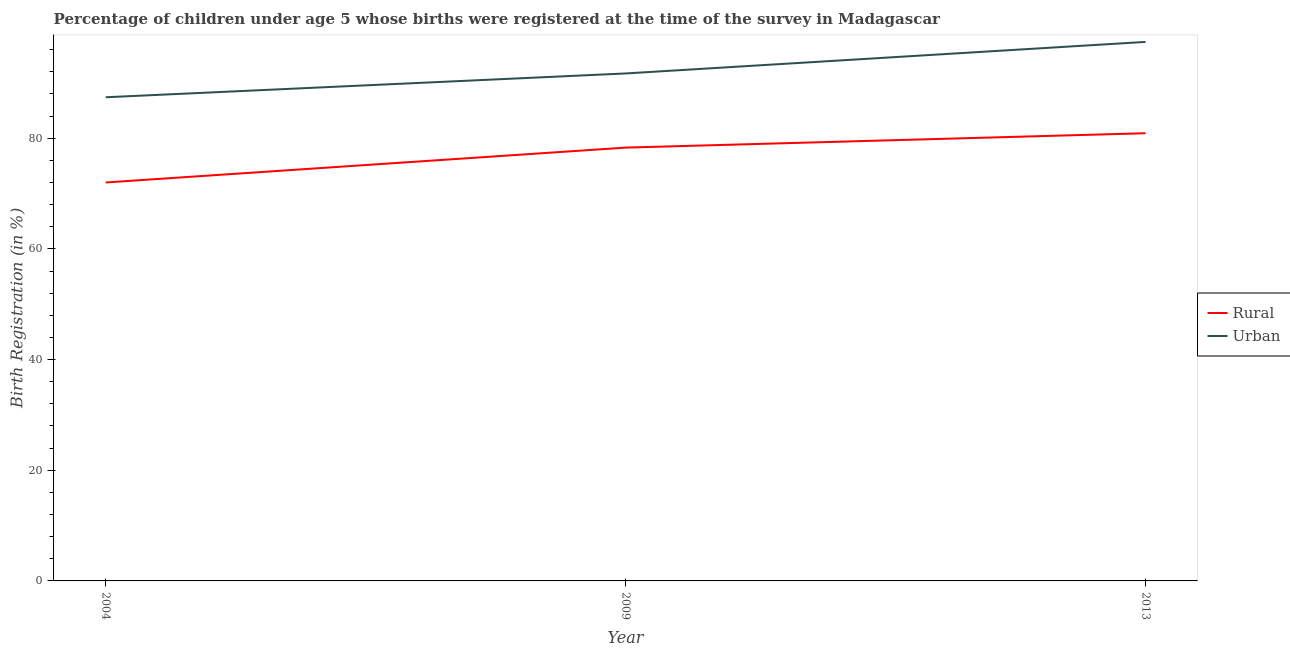Does the line corresponding to urban birth registration intersect with the line corresponding to rural birth registration?
Make the answer very short. No. What is the urban birth registration in 2009?
Give a very brief answer. 91.7. Across all years, what is the maximum urban birth registration?
Keep it short and to the point. 97.4. Across all years, what is the minimum rural birth registration?
Provide a short and direct response. 72. In which year was the rural birth registration maximum?
Ensure brevity in your answer.  2013. What is the total rural birth registration in the graph?
Offer a terse response. 231.2. What is the difference between the urban birth registration in 2004 and that in 2009?
Keep it short and to the point. -4.3. What is the average rural birth registration per year?
Give a very brief answer. 77.07. In the year 2013, what is the difference between the rural birth registration and urban birth registration?
Offer a terse response. -16.5. In how many years, is the rural birth registration greater than 80 %?
Offer a terse response. 1. What is the ratio of the rural birth registration in 2009 to that in 2013?
Your response must be concise. 0.97. Is the rural birth registration in 2004 less than that in 2009?
Provide a short and direct response. Yes. Is the difference between the rural birth registration in 2004 and 2013 greater than the difference between the urban birth registration in 2004 and 2013?
Offer a terse response. Yes. What is the difference between the highest and the second highest rural birth registration?
Offer a terse response. 2.6. What is the difference between the highest and the lowest rural birth registration?
Give a very brief answer. 8.9. Does the rural birth registration monotonically increase over the years?
Keep it short and to the point. Yes. How many lines are there?
Offer a terse response. 2. Does the graph contain any zero values?
Offer a terse response. No. Where does the legend appear in the graph?
Ensure brevity in your answer.  Center right. How many legend labels are there?
Provide a short and direct response. 2. What is the title of the graph?
Your answer should be very brief. Percentage of children under age 5 whose births were registered at the time of the survey in Madagascar. What is the label or title of the Y-axis?
Your response must be concise. Birth Registration (in %). What is the Birth Registration (in %) in Urban in 2004?
Your response must be concise. 87.4. What is the Birth Registration (in %) of Rural in 2009?
Your answer should be very brief. 78.3. What is the Birth Registration (in %) in Urban in 2009?
Ensure brevity in your answer.  91.7. What is the Birth Registration (in %) of Rural in 2013?
Offer a terse response. 80.9. What is the Birth Registration (in %) of Urban in 2013?
Keep it short and to the point. 97.4. Across all years, what is the maximum Birth Registration (in %) in Rural?
Your answer should be very brief. 80.9. Across all years, what is the maximum Birth Registration (in %) in Urban?
Your response must be concise. 97.4. Across all years, what is the minimum Birth Registration (in %) in Rural?
Give a very brief answer. 72. Across all years, what is the minimum Birth Registration (in %) in Urban?
Provide a short and direct response. 87.4. What is the total Birth Registration (in %) in Rural in the graph?
Offer a terse response. 231.2. What is the total Birth Registration (in %) of Urban in the graph?
Provide a short and direct response. 276.5. What is the difference between the Birth Registration (in %) of Urban in 2004 and that in 2009?
Offer a terse response. -4.3. What is the difference between the Birth Registration (in %) in Rural in 2004 and that in 2013?
Offer a very short reply. -8.9. What is the difference between the Birth Registration (in %) of Urban in 2004 and that in 2013?
Offer a very short reply. -10. What is the difference between the Birth Registration (in %) of Rural in 2009 and that in 2013?
Offer a terse response. -2.6. What is the difference between the Birth Registration (in %) of Rural in 2004 and the Birth Registration (in %) of Urban in 2009?
Your answer should be compact. -19.7. What is the difference between the Birth Registration (in %) in Rural in 2004 and the Birth Registration (in %) in Urban in 2013?
Provide a succinct answer. -25.4. What is the difference between the Birth Registration (in %) in Rural in 2009 and the Birth Registration (in %) in Urban in 2013?
Your response must be concise. -19.1. What is the average Birth Registration (in %) in Rural per year?
Give a very brief answer. 77.07. What is the average Birth Registration (in %) in Urban per year?
Your answer should be compact. 92.17. In the year 2004, what is the difference between the Birth Registration (in %) of Rural and Birth Registration (in %) of Urban?
Ensure brevity in your answer.  -15.4. In the year 2009, what is the difference between the Birth Registration (in %) in Rural and Birth Registration (in %) in Urban?
Your answer should be very brief. -13.4. In the year 2013, what is the difference between the Birth Registration (in %) of Rural and Birth Registration (in %) of Urban?
Give a very brief answer. -16.5. What is the ratio of the Birth Registration (in %) of Rural in 2004 to that in 2009?
Your response must be concise. 0.92. What is the ratio of the Birth Registration (in %) of Urban in 2004 to that in 2009?
Provide a short and direct response. 0.95. What is the ratio of the Birth Registration (in %) of Rural in 2004 to that in 2013?
Your answer should be very brief. 0.89. What is the ratio of the Birth Registration (in %) of Urban in 2004 to that in 2013?
Your response must be concise. 0.9. What is the ratio of the Birth Registration (in %) in Rural in 2009 to that in 2013?
Your answer should be very brief. 0.97. What is the ratio of the Birth Registration (in %) of Urban in 2009 to that in 2013?
Your answer should be compact. 0.94. What is the difference between the highest and the second highest Birth Registration (in %) in Urban?
Your answer should be very brief. 5.7. 